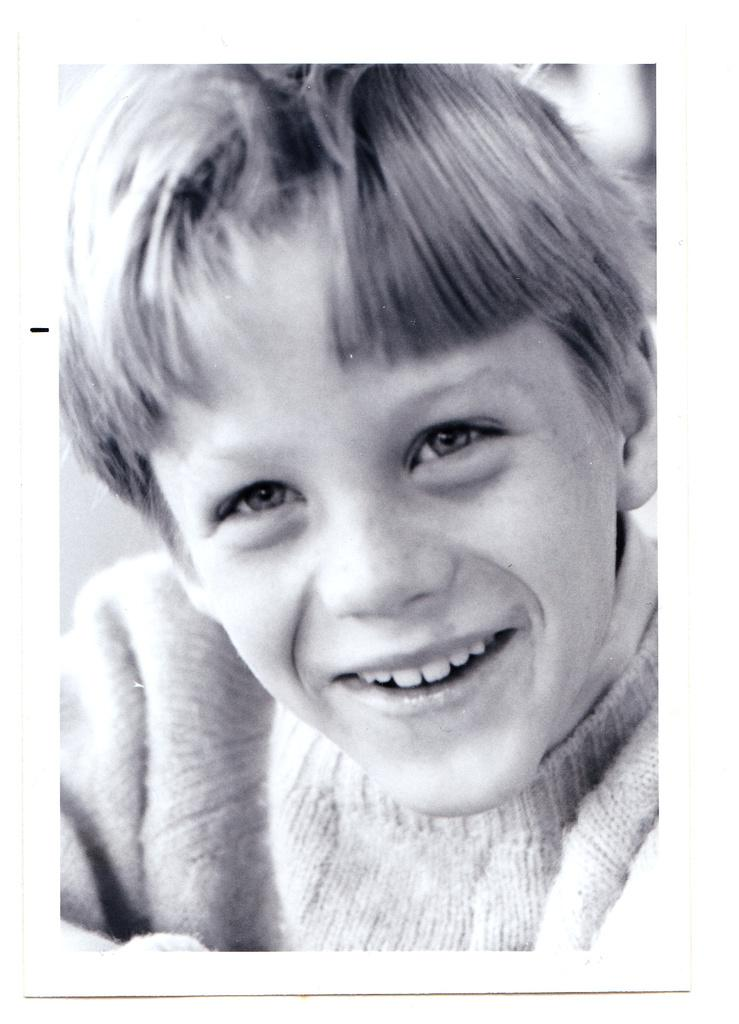What is the main subject of the image? There is a boy in the image. What is the boy's expression in the image? The boy is smiling in the image. What type of jar is the boy holding in the image? There is no jar present in the image; the boy is not holding anything. 